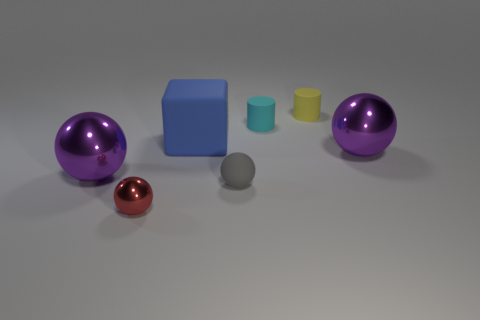Considering their arrangement, what could be the purpose of these objects? The objects are arranged in a manner that doesn't seem to serve a functional purpose but rather suggests a display or a study of shapes, materials, and reflections. It resembles a still life composition, where the arrangement and variety of shapes invite contemplation and aesthetic appreciation rather than practical use. If this were part of an exercise, it could be used to teach or demonstrate the principles of geometry, material properties, or visual composition in art or photography. 